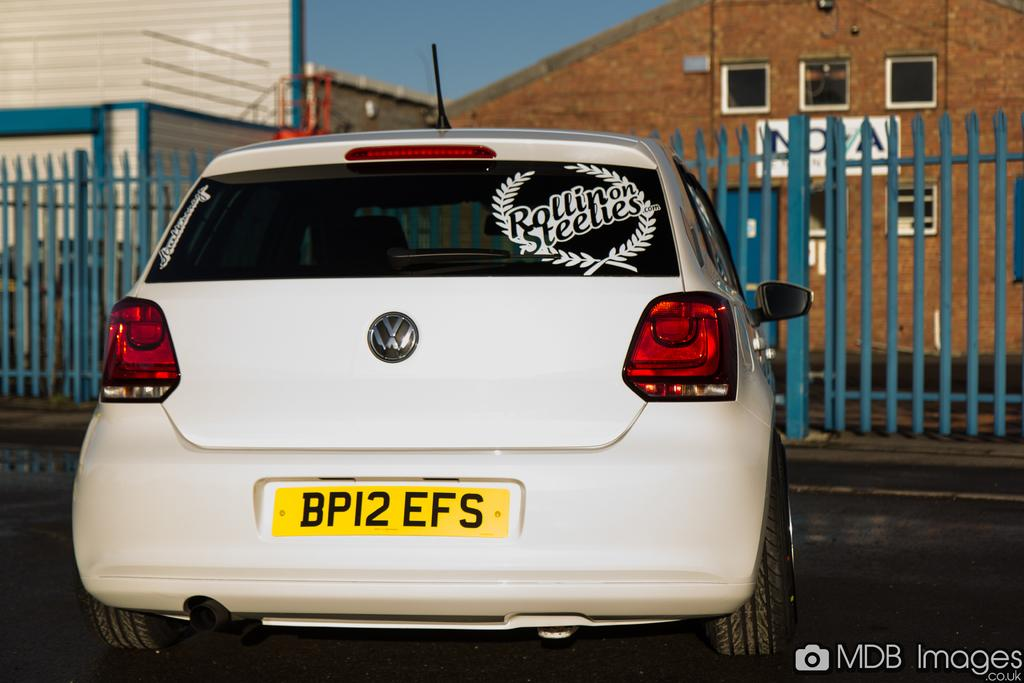<image>
Describe the image concisely. A decal in the back window of a car says Rollin on Steelies. 